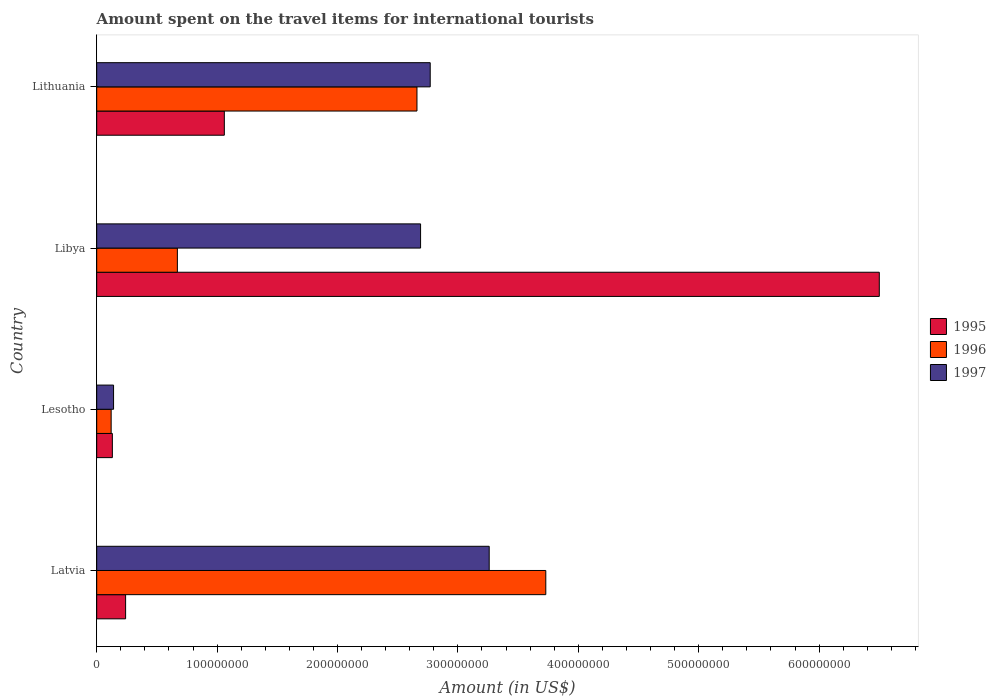Are the number of bars per tick equal to the number of legend labels?
Your answer should be very brief. Yes. Are the number of bars on each tick of the Y-axis equal?
Give a very brief answer. Yes. What is the label of the 1st group of bars from the top?
Ensure brevity in your answer.  Lithuania. Across all countries, what is the maximum amount spent on the travel items for international tourists in 1995?
Provide a short and direct response. 6.50e+08. Across all countries, what is the minimum amount spent on the travel items for international tourists in 1995?
Give a very brief answer. 1.30e+07. In which country was the amount spent on the travel items for international tourists in 1995 maximum?
Your response must be concise. Libya. In which country was the amount spent on the travel items for international tourists in 1996 minimum?
Make the answer very short. Lesotho. What is the total amount spent on the travel items for international tourists in 1996 in the graph?
Offer a terse response. 7.18e+08. What is the difference between the amount spent on the travel items for international tourists in 1997 in Latvia and that in Lithuania?
Offer a very short reply. 4.90e+07. What is the difference between the amount spent on the travel items for international tourists in 1997 in Lithuania and the amount spent on the travel items for international tourists in 1996 in Latvia?
Provide a short and direct response. -9.60e+07. What is the average amount spent on the travel items for international tourists in 1995 per country?
Provide a succinct answer. 1.98e+08. What is the difference between the amount spent on the travel items for international tourists in 1997 and amount spent on the travel items for international tourists in 1995 in Lesotho?
Provide a succinct answer. 1.00e+06. In how many countries, is the amount spent on the travel items for international tourists in 1997 greater than 220000000 US$?
Your response must be concise. 3. What is the ratio of the amount spent on the travel items for international tourists in 1995 in Lesotho to that in Lithuania?
Keep it short and to the point. 0.12. Is the amount spent on the travel items for international tourists in 1996 in Latvia less than that in Lesotho?
Offer a very short reply. No. What is the difference between the highest and the second highest amount spent on the travel items for international tourists in 1997?
Offer a terse response. 4.90e+07. What is the difference between the highest and the lowest amount spent on the travel items for international tourists in 1996?
Your answer should be very brief. 3.61e+08. In how many countries, is the amount spent on the travel items for international tourists in 1997 greater than the average amount spent on the travel items for international tourists in 1997 taken over all countries?
Make the answer very short. 3. Is the sum of the amount spent on the travel items for international tourists in 1996 in Libya and Lithuania greater than the maximum amount spent on the travel items for international tourists in 1997 across all countries?
Your answer should be compact. Yes. What does the 2nd bar from the top in Lithuania represents?
Your answer should be compact. 1996. What does the 1st bar from the bottom in Latvia represents?
Make the answer very short. 1995. Does the graph contain grids?
Provide a short and direct response. No. How many legend labels are there?
Your response must be concise. 3. What is the title of the graph?
Make the answer very short. Amount spent on the travel items for international tourists. What is the label or title of the Y-axis?
Provide a short and direct response. Country. What is the Amount (in US$) in 1995 in Latvia?
Give a very brief answer. 2.40e+07. What is the Amount (in US$) in 1996 in Latvia?
Provide a succinct answer. 3.73e+08. What is the Amount (in US$) of 1997 in Latvia?
Make the answer very short. 3.26e+08. What is the Amount (in US$) in 1995 in Lesotho?
Ensure brevity in your answer.  1.30e+07. What is the Amount (in US$) of 1997 in Lesotho?
Make the answer very short. 1.40e+07. What is the Amount (in US$) of 1995 in Libya?
Your answer should be very brief. 6.50e+08. What is the Amount (in US$) of 1996 in Libya?
Make the answer very short. 6.70e+07. What is the Amount (in US$) of 1997 in Libya?
Give a very brief answer. 2.69e+08. What is the Amount (in US$) in 1995 in Lithuania?
Make the answer very short. 1.06e+08. What is the Amount (in US$) of 1996 in Lithuania?
Offer a terse response. 2.66e+08. What is the Amount (in US$) in 1997 in Lithuania?
Give a very brief answer. 2.77e+08. Across all countries, what is the maximum Amount (in US$) of 1995?
Offer a very short reply. 6.50e+08. Across all countries, what is the maximum Amount (in US$) in 1996?
Your response must be concise. 3.73e+08. Across all countries, what is the maximum Amount (in US$) in 1997?
Provide a succinct answer. 3.26e+08. Across all countries, what is the minimum Amount (in US$) of 1995?
Keep it short and to the point. 1.30e+07. Across all countries, what is the minimum Amount (in US$) of 1996?
Offer a very short reply. 1.20e+07. Across all countries, what is the minimum Amount (in US$) of 1997?
Keep it short and to the point. 1.40e+07. What is the total Amount (in US$) in 1995 in the graph?
Ensure brevity in your answer.  7.93e+08. What is the total Amount (in US$) of 1996 in the graph?
Give a very brief answer. 7.18e+08. What is the total Amount (in US$) of 1997 in the graph?
Make the answer very short. 8.86e+08. What is the difference between the Amount (in US$) of 1995 in Latvia and that in Lesotho?
Offer a very short reply. 1.10e+07. What is the difference between the Amount (in US$) in 1996 in Latvia and that in Lesotho?
Provide a succinct answer. 3.61e+08. What is the difference between the Amount (in US$) in 1997 in Latvia and that in Lesotho?
Provide a short and direct response. 3.12e+08. What is the difference between the Amount (in US$) of 1995 in Latvia and that in Libya?
Your answer should be compact. -6.26e+08. What is the difference between the Amount (in US$) in 1996 in Latvia and that in Libya?
Your answer should be very brief. 3.06e+08. What is the difference between the Amount (in US$) in 1997 in Latvia and that in Libya?
Offer a terse response. 5.70e+07. What is the difference between the Amount (in US$) in 1995 in Latvia and that in Lithuania?
Your response must be concise. -8.20e+07. What is the difference between the Amount (in US$) in 1996 in Latvia and that in Lithuania?
Keep it short and to the point. 1.07e+08. What is the difference between the Amount (in US$) in 1997 in Latvia and that in Lithuania?
Make the answer very short. 4.90e+07. What is the difference between the Amount (in US$) of 1995 in Lesotho and that in Libya?
Keep it short and to the point. -6.37e+08. What is the difference between the Amount (in US$) of 1996 in Lesotho and that in Libya?
Offer a terse response. -5.50e+07. What is the difference between the Amount (in US$) of 1997 in Lesotho and that in Libya?
Keep it short and to the point. -2.55e+08. What is the difference between the Amount (in US$) of 1995 in Lesotho and that in Lithuania?
Provide a short and direct response. -9.30e+07. What is the difference between the Amount (in US$) of 1996 in Lesotho and that in Lithuania?
Provide a succinct answer. -2.54e+08. What is the difference between the Amount (in US$) of 1997 in Lesotho and that in Lithuania?
Your answer should be compact. -2.63e+08. What is the difference between the Amount (in US$) of 1995 in Libya and that in Lithuania?
Ensure brevity in your answer.  5.44e+08. What is the difference between the Amount (in US$) of 1996 in Libya and that in Lithuania?
Your answer should be very brief. -1.99e+08. What is the difference between the Amount (in US$) in 1997 in Libya and that in Lithuania?
Provide a short and direct response. -8.00e+06. What is the difference between the Amount (in US$) of 1995 in Latvia and the Amount (in US$) of 1997 in Lesotho?
Give a very brief answer. 1.00e+07. What is the difference between the Amount (in US$) in 1996 in Latvia and the Amount (in US$) in 1997 in Lesotho?
Keep it short and to the point. 3.59e+08. What is the difference between the Amount (in US$) in 1995 in Latvia and the Amount (in US$) in 1996 in Libya?
Provide a short and direct response. -4.30e+07. What is the difference between the Amount (in US$) of 1995 in Latvia and the Amount (in US$) of 1997 in Libya?
Give a very brief answer. -2.45e+08. What is the difference between the Amount (in US$) of 1996 in Latvia and the Amount (in US$) of 1997 in Libya?
Offer a very short reply. 1.04e+08. What is the difference between the Amount (in US$) in 1995 in Latvia and the Amount (in US$) in 1996 in Lithuania?
Keep it short and to the point. -2.42e+08. What is the difference between the Amount (in US$) in 1995 in Latvia and the Amount (in US$) in 1997 in Lithuania?
Give a very brief answer. -2.53e+08. What is the difference between the Amount (in US$) of 1996 in Latvia and the Amount (in US$) of 1997 in Lithuania?
Give a very brief answer. 9.60e+07. What is the difference between the Amount (in US$) in 1995 in Lesotho and the Amount (in US$) in 1996 in Libya?
Your answer should be compact. -5.40e+07. What is the difference between the Amount (in US$) in 1995 in Lesotho and the Amount (in US$) in 1997 in Libya?
Offer a very short reply. -2.56e+08. What is the difference between the Amount (in US$) in 1996 in Lesotho and the Amount (in US$) in 1997 in Libya?
Provide a short and direct response. -2.57e+08. What is the difference between the Amount (in US$) in 1995 in Lesotho and the Amount (in US$) in 1996 in Lithuania?
Your answer should be very brief. -2.53e+08. What is the difference between the Amount (in US$) of 1995 in Lesotho and the Amount (in US$) of 1997 in Lithuania?
Ensure brevity in your answer.  -2.64e+08. What is the difference between the Amount (in US$) of 1996 in Lesotho and the Amount (in US$) of 1997 in Lithuania?
Make the answer very short. -2.65e+08. What is the difference between the Amount (in US$) in 1995 in Libya and the Amount (in US$) in 1996 in Lithuania?
Ensure brevity in your answer.  3.84e+08. What is the difference between the Amount (in US$) in 1995 in Libya and the Amount (in US$) in 1997 in Lithuania?
Offer a terse response. 3.73e+08. What is the difference between the Amount (in US$) in 1996 in Libya and the Amount (in US$) in 1997 in Lithuania?
Your response must be concise. -2.10e+08. What is the average Amount (in US$) of 1995 per country?
Keep it short and to the point. 1.98e+08. What is the average Amount (in US$) in 1996 per country?
Your response must be concise. 1.80e+08. What is the average Amount (in US$) of 1997 per country?
Your response must be concise. 2.22e+08. What is the difference between the Amount (in US$) of 1995 and Amount (in US$) of 1996 in Latvia?
Keep it short and to the point. -3.49e+08. What is the difference between the Amount (in US$) in 1995 and Amount (in US$) in 1997 in Latvia?
Keep it short and to the point. -3.02e+08. What is the difference between the Amount (in US$) of 1996 and Amount (in US$) of 1997 in Latvia?
Provide a succinct answer. 4.70e+07. What is the difference between the Amount (in US$) of 1995 and Amount (in US$) of 1996 in Lesotho?
Offer a very short reply. 1.00e+06. What is the difference between the Amount (in US$) in 1996 and Amount (in US$) in 1997 in Lesotho?
Offer a very short reply. -2.00e+06. What is the difference between the Amount (in US$) in 1995 and Amount (in US$) in 1996 in Libya?
Provide a succinct answer. 5.83e+08. What is the difference between the Amount (in US$) in 1995 and Amount (in US$) in 1997 in Libya?
Your answer should be compact. 3.81e+08. What is the difference between the Amount (in US$) of 1996 and Amount (in US$) of 1997 in Libya?
Your answer should be compact. -2.02e+08. What is the difference between the Amount (in US$) of 1995 and Amount (in US$) of 1996 in Lithuania?
Offer a terse response. -1.60e+08. What is the difference between the Amount (in US$) in 1995 and Amount (in US$) in 1997 in Lithuania?
Give a very brief answer. -1.71e+08. What is the difference between the Amount (in US$) of 1996 and Amount (in US$) of 1997 in Lithuania?
Ensure brevity in your answer.  -1.10e+07. What is the ratio of the Amount (in US$) of 1995 in Latvia to that in Lesotho?
Make the answer very short. 1.85. What is the ratio of the Amount (in US$) in 1996 in Latvia to that in Lesotho?
Your answer should be very brief. 31.08. What is the ratio of the Amount (in US$) in 1997 in Latvia to that in Lesotho?
Offer a terse response. 23.29. What is the ratio of the Amount (in US$) of 1995 in Latvia to that in Libya?
Your answer should be compact. 0.04. What is the ratio of the Amount (in US$) in 1996 in Latvia to that in Libya?
Keep it short and to the point. 5.57. What is the ratio of the Amount (in US$) of 1997 in Latvia to that in Libya?
Keep it short and to the point. 1.21. What is the ratio of the Amount (in US$) in 1995 in Latvia to that in Lithuania?
Make the answer very short. 0.23. What is the ratio of the Amount (in US$) in 1996 in Latvia to that in Lithuania?
Your answer should be very brief. 1.4. What is the ratio of the Amount (in US$) of 1997 in Latvia to that in Lithuania?
Your answer should be very brief. 1.18. What is the ratio of the Amount (in US$) in 1996 in Lesotho to that in Libya?
Your answer should be very brief. 0.18. What is the ratio of the Amount (in US$) in 1997 in Lesotho to that in Libya?
Give a very brief answer. 0.05. What is the ratio of the Amount (in US$) in 1995 in Lesotho to that in Lithuania?
Your answer should be compact. 0.12. What is the ratio of the Amount (in US$) of 1996 in Lesotho to that in Lithuania?
Offer a very short reply. 0.05. What is the ratio of the Amount (in US$) of 1997 in Lesotho to that in Lithuania?
Ensure brevity in your answer.  0.05. What is the ratio of the Amount (in US$) in 1995 in Libya to that in Lithuania?
Make the answer very short. 6.13. What is the ratio of the Amount (in US$) in 1996 in Libya to that in Lithuania?
Your response must be concise. 0.25. What is the ratio of the Amount (in US$) of 1997 in Libya to that in Lithuania?
Offer a very short reply. 0.97. What is the difference between the highest and the second highest Amount (in US$) of 1995?
Give a very brief answer. 5.44e+08. What is the difference between the highest and the second highest Amount (in US$) of 1996?
Your response must be concise. 1.07e+08. What is the difference between the highest and the second highest Amount (in US$) in 1997?
Your response must be concise. 4.90e+07. What is the difference between the highest and the lowest Amount (in US$) of 1995?
Provide a succinct answer. 6.37e+08. What is the difference between the highest and the lowest Amount (in US$) in 1996?
Provide a succinct answer. 3.61e+08. What is the difference between the highest and the lowest Amount (in US$) of 1997?
Give a very brief answer. 3.12e+08. 